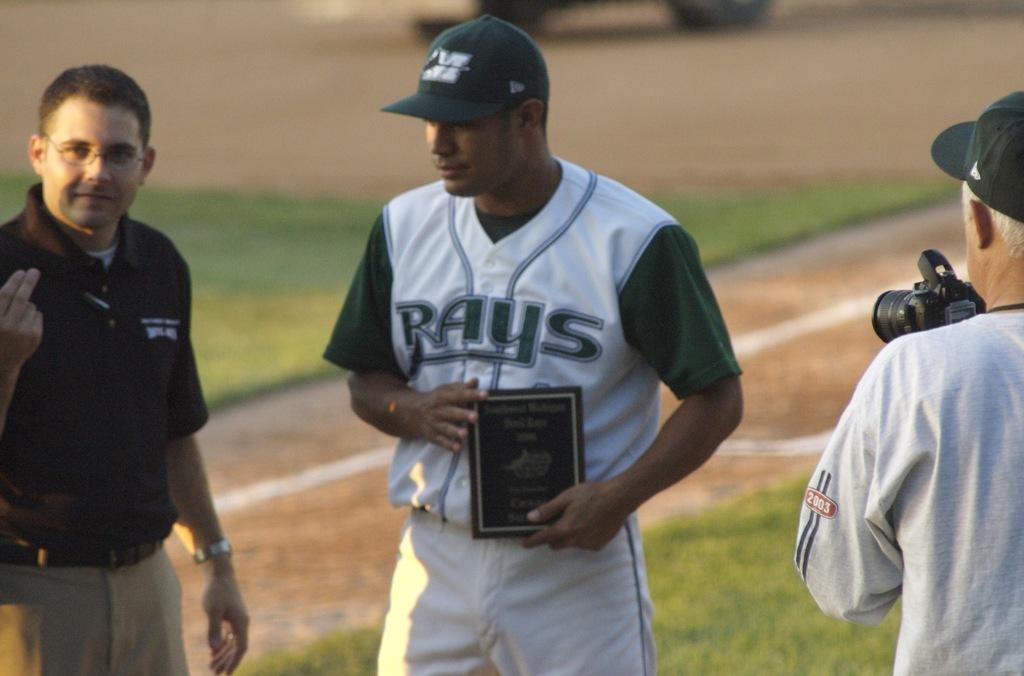What is the teams name on the players jersey?
Your response must be concise. Rays. What year is shown on the photographer's shirt?
Ensure brevity in your answer.  2003. 